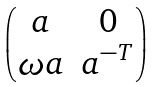Convert formula to latex. <formula><loc_0><loc_0><loc_500><loc_500>\begin{pmatrix} a & 0 \\ \omega a & a ^ { - T } \end{pmatrix}</formula> 